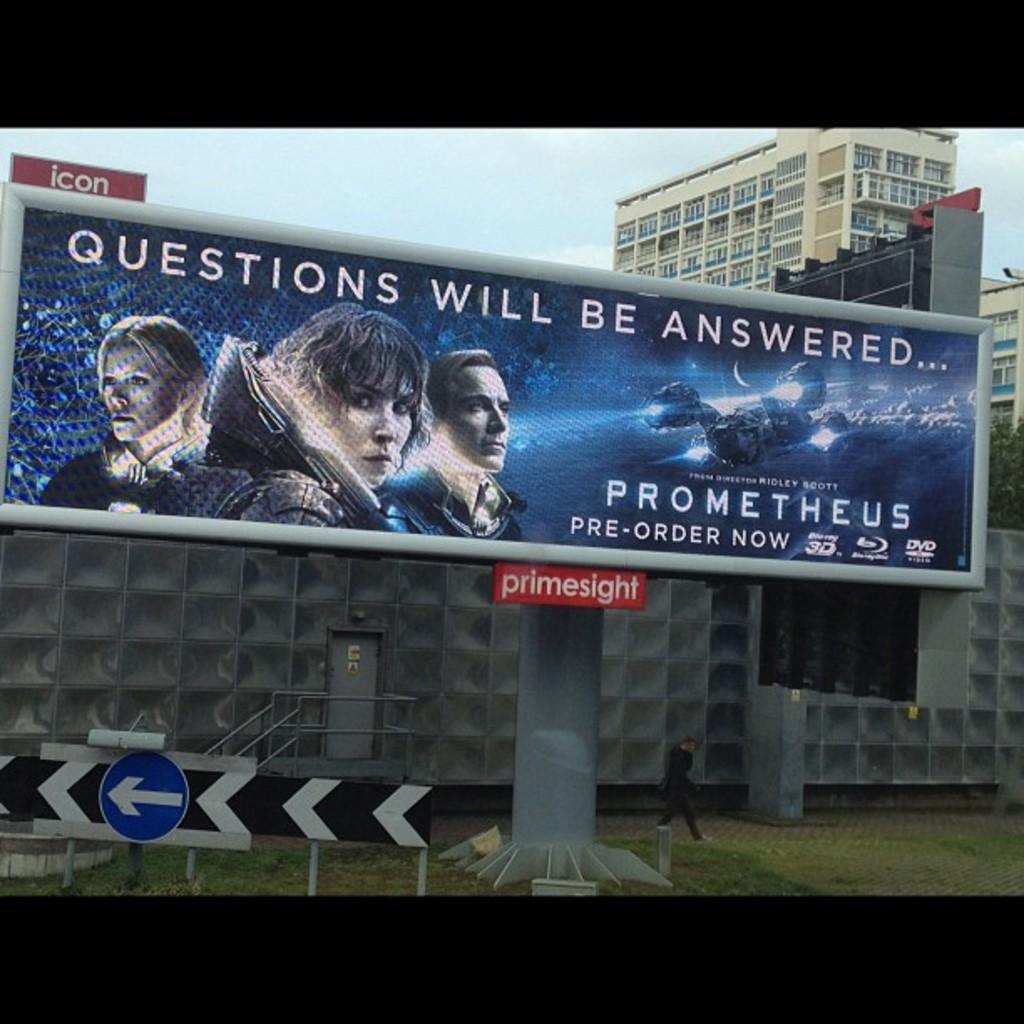<image>
Relay a brief, clear account of the picture shown. A billboard features an advertisement for the movie Prometheus. 